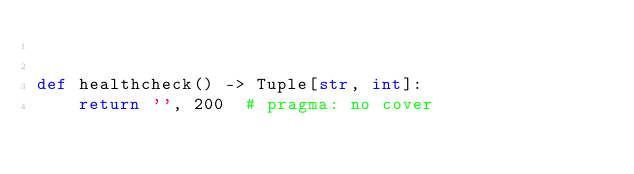Convert code to text. <code><loc_0><loc_0><loc_500><loc_500><_Python_>

def healthcheck() -> Tuple[str, int]:
    return '', 200  # pragma: no cover
</code> 